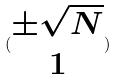<formula> <loc_0><loc_0><loc_500><loc_500>( \begin{matrix} \pm \sqrt { N } \\ 1 \end{matrix} )</formula> 